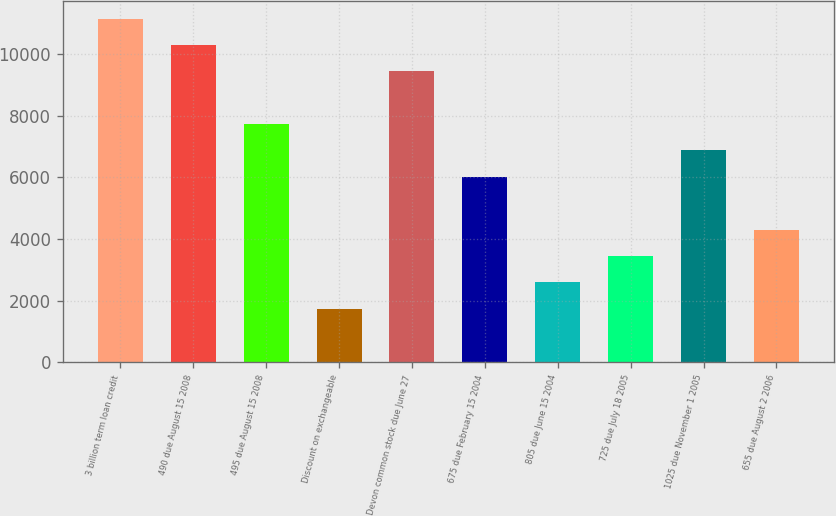Convert chart. <chart><loc_0><loc_0><loc_500><loc_500><bar_chart><fcel>3 billion term loan credit<fcel>490 due August 15 2008<fcel>495 due August 15 2008<fcel>Discount on exchangeable<fcel>Devon common stock due June 27<fcel>675 due February 15 2004<fcel>805 due June 15 2004<fcel>725 due July 18 2005<fcel>1025 due November 1 2005<fcel>655 due August 2 2006<nl><fcel>11145.9<fcel>10290.6<fcel>7724.7<fcel>1737.6<fcel>9435.3<fcel>6014.1<fcel>2592.9<fcel>3448.2<fcel>6869.4<fcel>4303.5<nl></chart> 